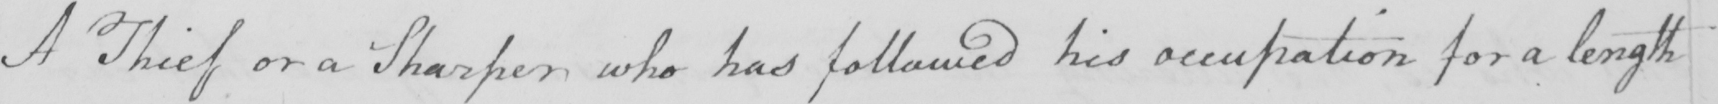Can you tell me what this handwritten text says? A Thief or a Sharper who has followed his occupation for a length 